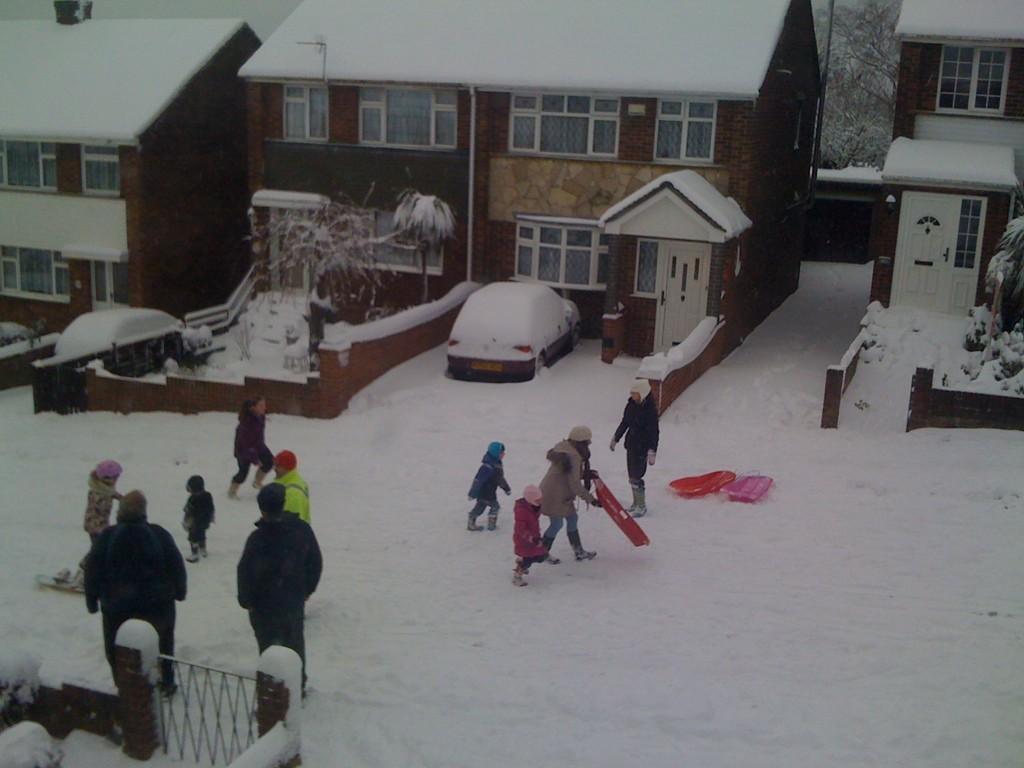What type of barrier can be seen in the image? There is a metal fence in the image. What is the surface that the people are standing on? The people are standing on the snow. What can be found on the surface besides the people? There are objects on the surface. What type of vehicles are present in the image? There are cars in the image. What structures can be seen in the image? There are buildings in the image. What type of vegetation is present in the image? There are trees in the image. What type of body of water is visible in the image? There is no body of water visible in the image. How many bags of popcorn can be seen in the image? There are no bags of popcorn present in the image. 